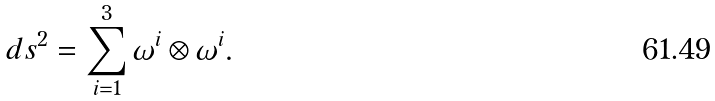<formula> <loc_0><loc_0><loc_500><loc_500>d s ^ { 2 } = \sum _ { i = 1 } ^ { 3 } \omega ^ { i } \otimes \omega ^ { i } .</formula> 